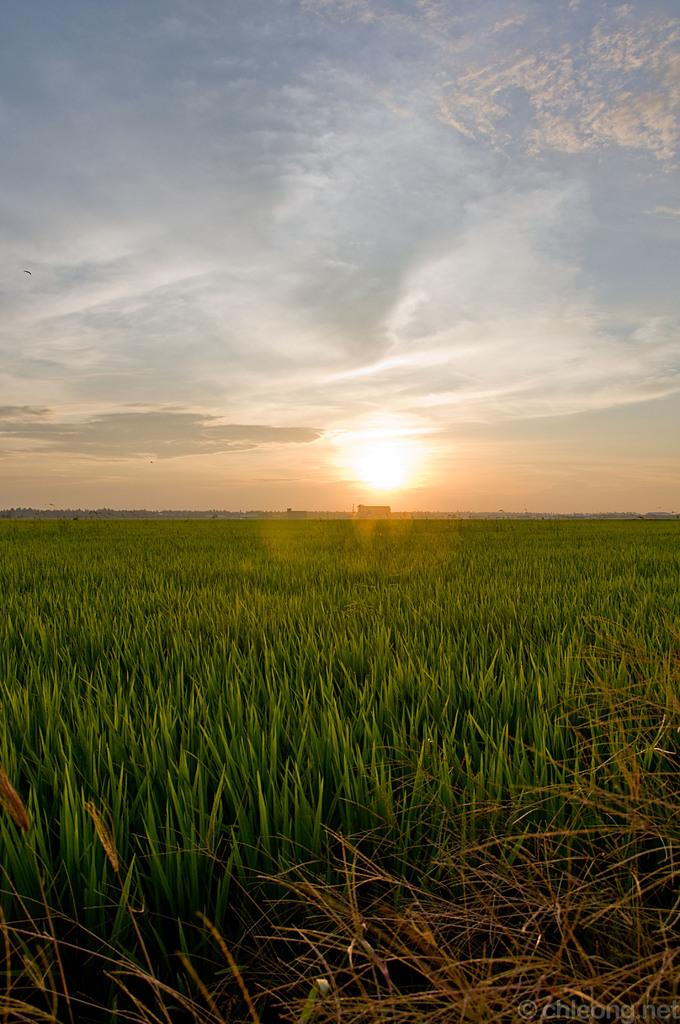What type of landscape is depicted in the image? The image features fields. What else can be seen in the image besides the fields? There is a vehicle and trees in the image. What is the condition of the sky in the image? The sun is visible in the sky at the top of the image. How many rings are visible on the vehicle in the image? There are no rings visible on the vehicle in the image. What type of crate is being used to transport the trees in the image? There is no crate present in the image, and the trees are not being transported. 